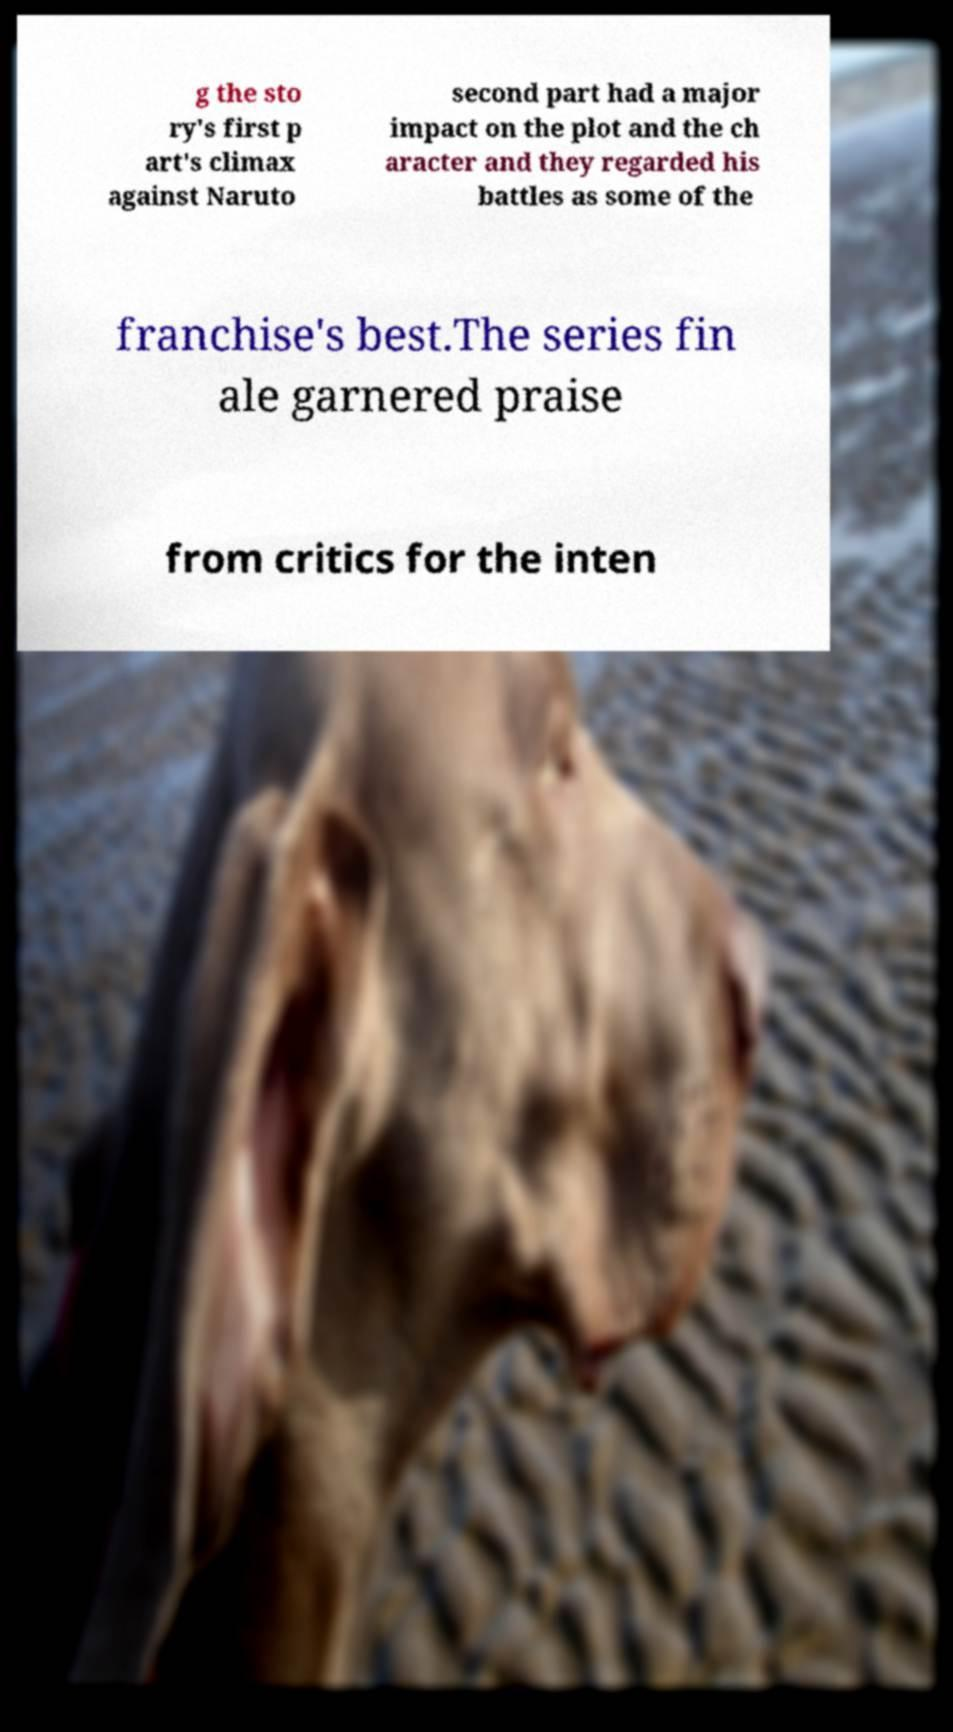There's text embedded in this image that I need extracted. Can you transcribe it verbatim? g the sto ry's first p art's climax against Naruto second part had a major impact on the plot and the ch aracter and they regarded his battles as some of the franchise's best.The series fin ale garnered praise from critics for the inten 